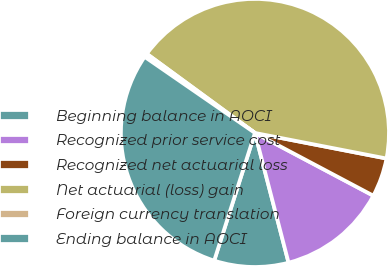<chart> <loc_0><loc_0><loc_500><loc_500><pie_chart><fcel>Beginning balance in AOCI<fcel>Recognized prior service cost<fcel>Recognized net actuarial loss<fcel>Net actuarial (loss) gain<fcel>Foreign currency translation<fcel>Ending balance in AOCI<nl><fcel>8.95%<fcel>13.21%<fcel>4.7%<fcel>43.0%<fcel>0.44%<fcel>29.7%<nl></chart> 